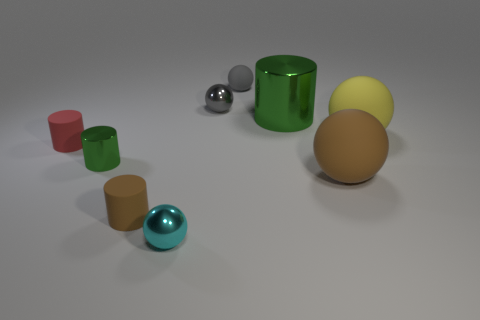Subtract all spheres. How many objects are left? 4 Subtract all green matte cylinders. Subtract all big green cylinders. How many objects are left? 8 Add 5 small matte spheres. How many small matte spheres are left? 6 Add 2 yellow rubber objects. How many yellow rubber objects exist? 3 Subtract 0 blue blocks. How many objects are left? 9 